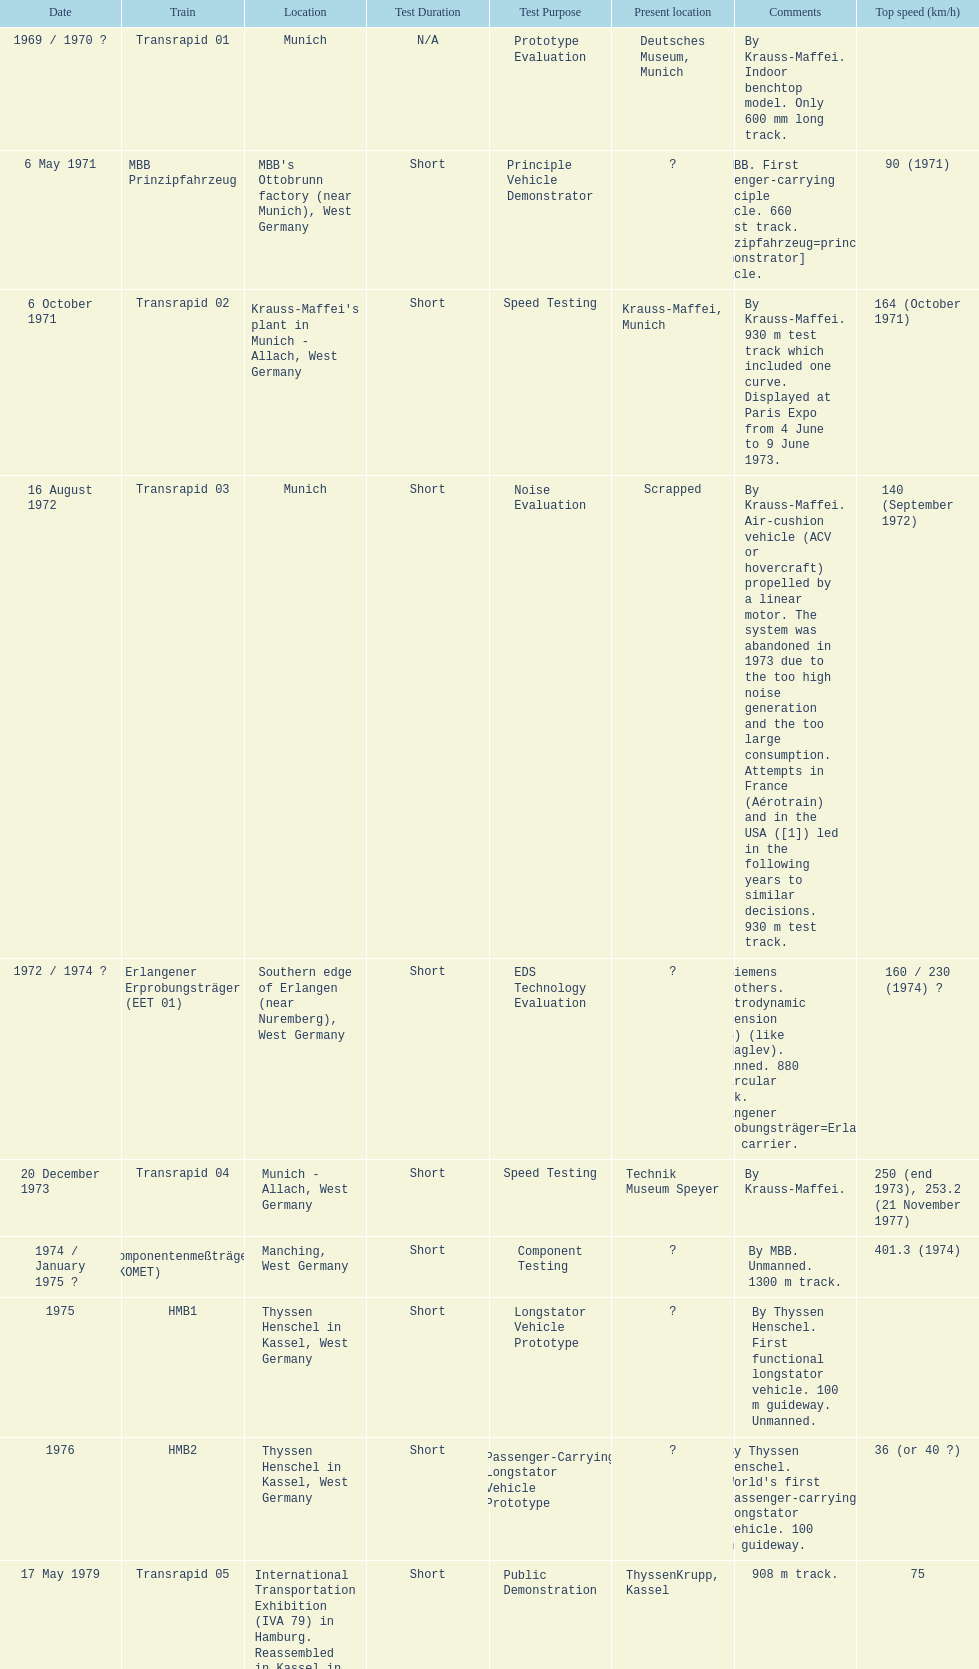Tell me the number of versions that are scrapped. 1. 